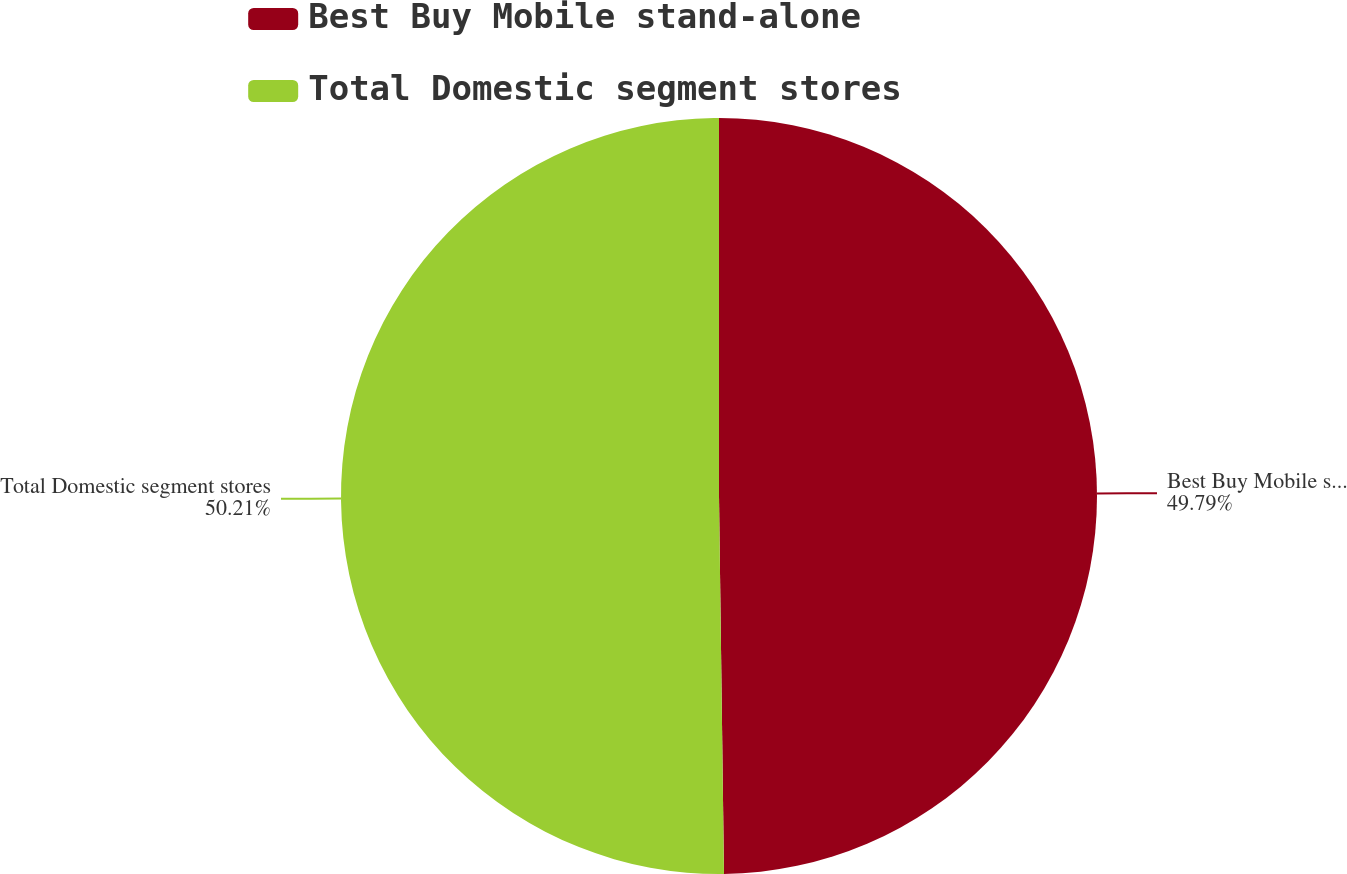Convert chart. <chart><loc_0><loc_0><loc_500><loc_500><pie_chart><fcel>Best Buy Mobile stand-alone<fcel>Total Domestic segment stores<nl><fcel>49.79%<fcel>50.21%<nl></chart> 